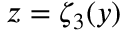Convert formula to latex. <formula><loc_0><loc_0><loc_500><loc_500>z = \zeta _ { 3 } ( y )</formula> 